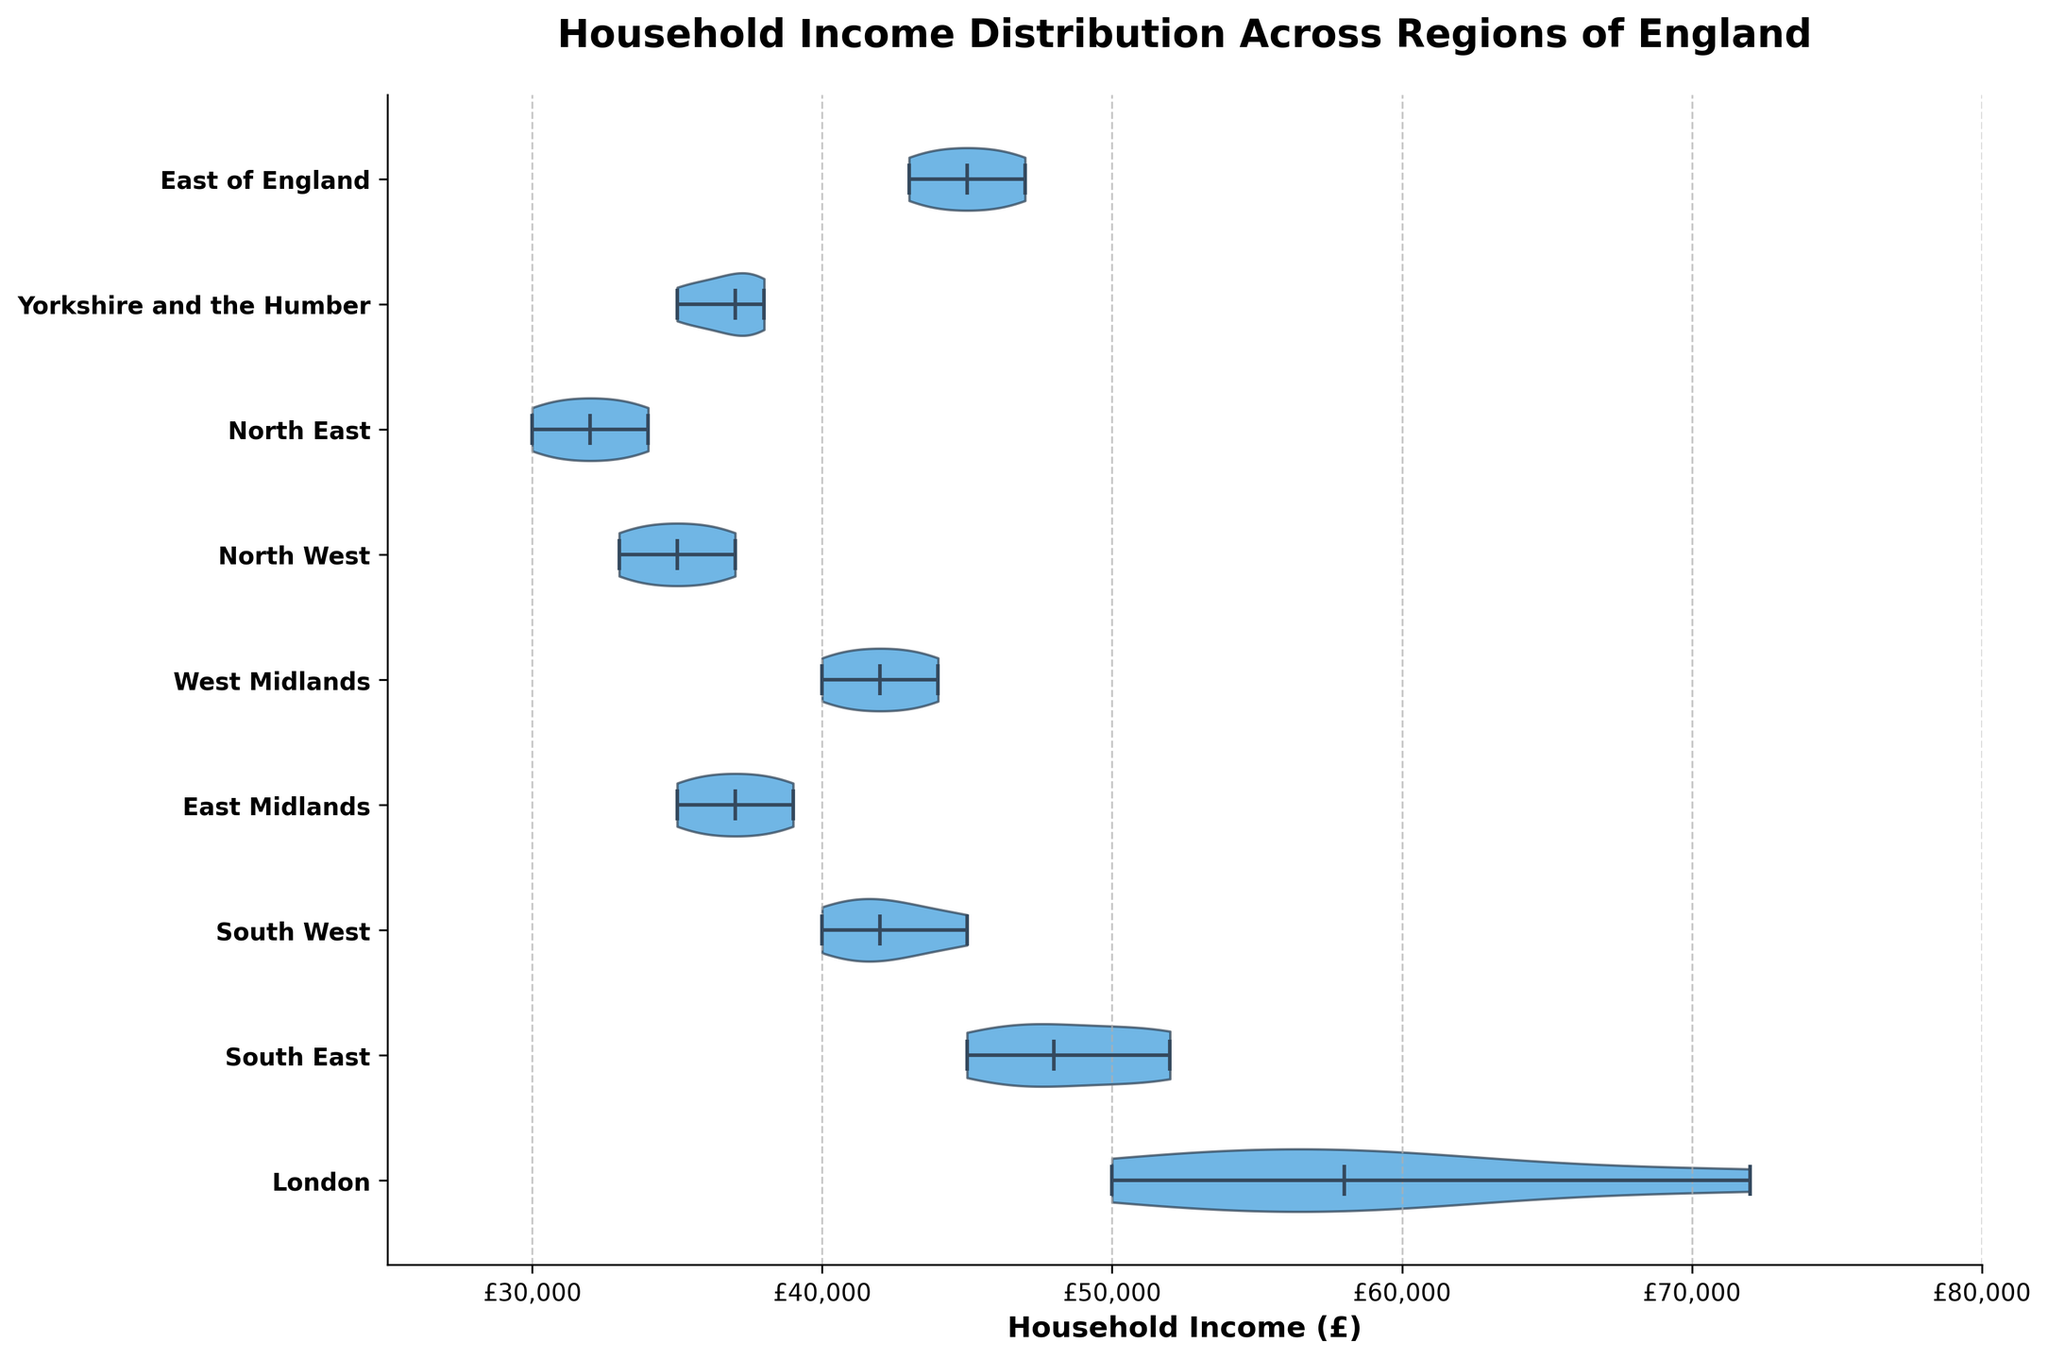what is the title of the chart? The title of the chart is placed at the top, and it is usually the largest text element. By looking at the top center of the chart, we can identify the title.
Answer: Household Income Distribution Across Regions of England how many regions are displayed in the chart? The regions are labeled on the y-axis, one label per region. By counting these labels, we can determine the number of regions.
Answer: 9 which region has the highest median household income? The median is indicated by the horizontal line inside each violin plot. By comparing the positions of these lines across all regions, we can identify the region with the highest median.
Answer: London what is the household income range in the North East region? The ends of the violin plot represent the range of household income. By identifying the minimum and maximum points of the violin plot for the North East region, we can determine the range.
Answer: £30,000 to £34,000 which region has the widest distribution of household incomes? The width of the violin plot represents the distribution. The region with the widest plot indicates a higher variation in household incomes.
Answer: London how does the median household income in the South West compare to the East of England? By locating the median lines in the violin plots for both South West and East of England, we can compare their vertical positions to see which is higher.
Answer: South West is lower which regions have a median household income above £40,000? The median line inside the violin plot that crosses the £40,000 mark can be identified by looking at the median line's position relative to the x-axis marks.
Answer: London, South East, East of England, West Midlands what can be said about the household income distribution in Yorkshire and the Humber? Observe the shape and spread of the violin plot for Yorkshire and the Humber. If it is narrow and centered, it indicates low variability, while a wider shape indicates higher variability.
Answer: Narrower distribution around £35,000 how does the household income distribution in London compare to the North West? By comparing the shapes and spreads of the violin plots for these two regions, we can infer differences in variability and income levels.
Answer: London is higher and more variable 